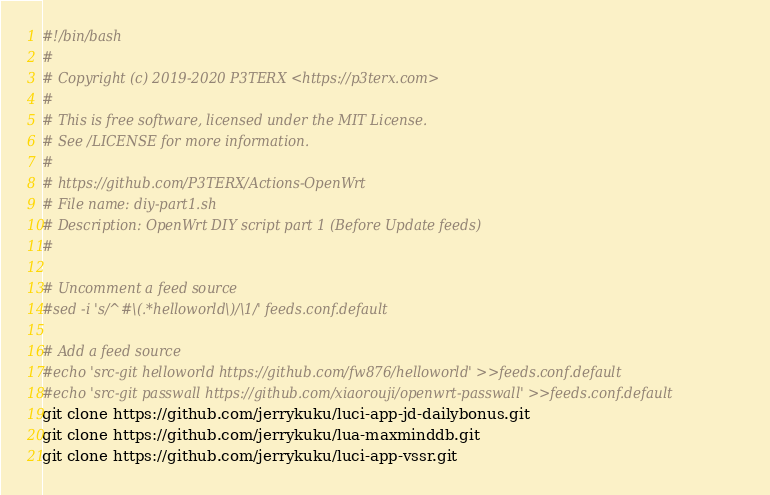<code> <loc_0><loc_0><loc_500><loc_500><_Bash_>#!/bin/bash
#
# Copyright (c) 2019-2020 P3TERX <https://p3terx.com>
#
# This is free software, licensed under the MIT License.
# See /LICENSE for more information.
#
# https://github.com/P3TERX/Actions-OpenWrt
# File name: diy-part1.sh
# Description: OpenWrt DIY script part 1 (Before Update feeds)
#

# Uncomment a feed source
#sed -i 's/^#\(.*helloworld\)/\1/' feeds.conf.default

# Add a feed source
#echo 'src-git helloworld https://github.com/fw876/helloworld' >>feeds.conf.default
#echo 'src-git passwall https://github.com/xiaorouji/openwrt-passwall' >>feeds.conf.default
git clone https://github.com/jerrykuku/luci-app-jd-dailybonus.git
git clone https://github.com/jerrykuku/lua-maxminddb.git
git clone https://github.com/jerrykuku/luci-app-vssr.git  
</code> 